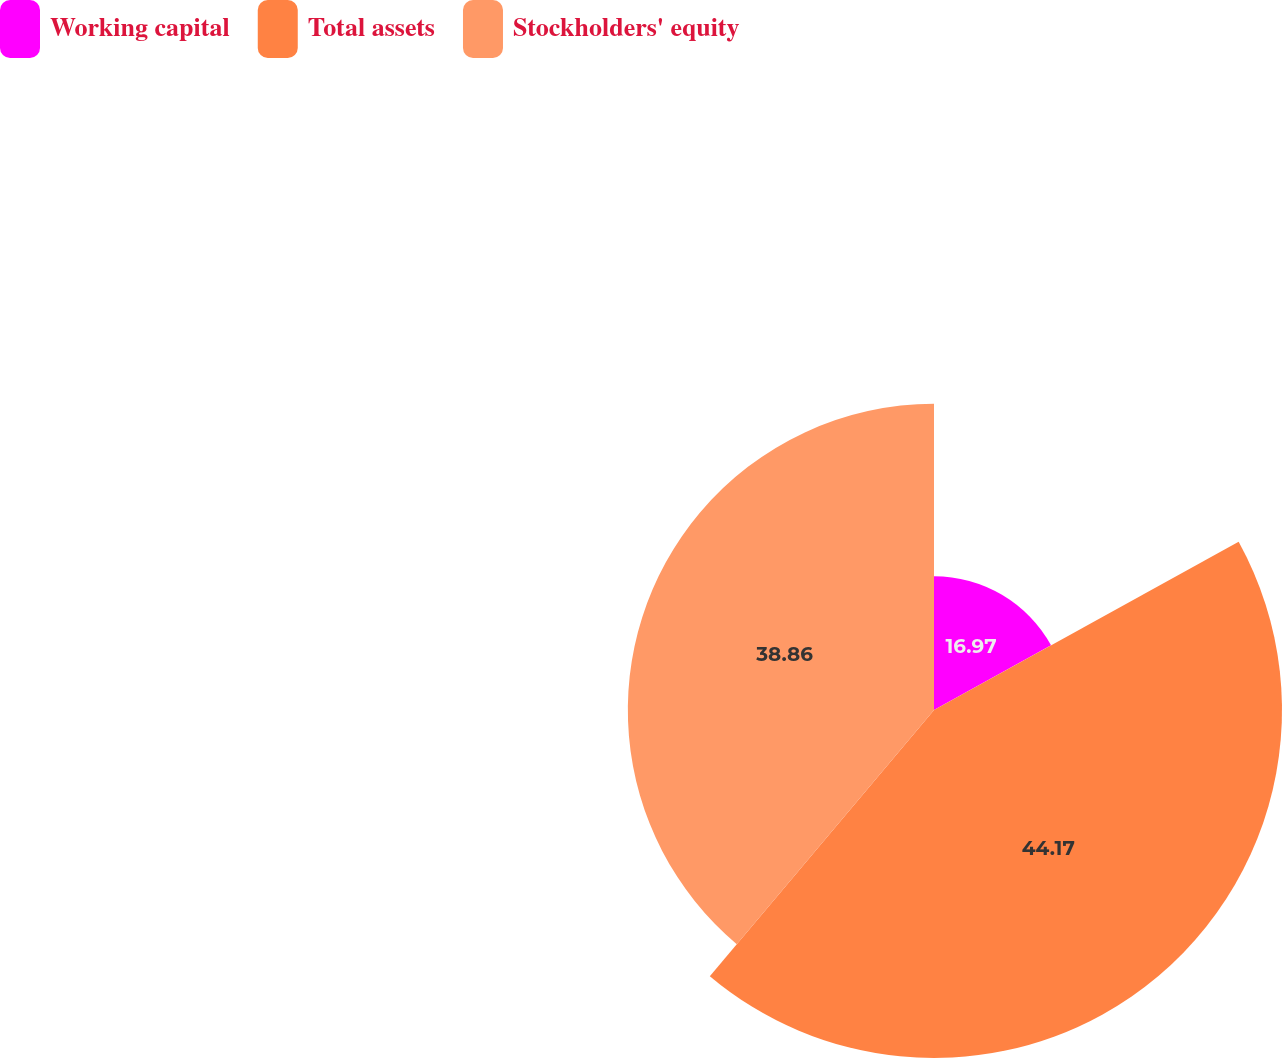Convert chart to OTSL. <chart><loc_0><loc_0><loc_500><loc_500><pie_chart><fcel>Working capital<fcel>Total assets<fcel>Stockholders' equity<nl><fcel>16.97%<fcel>44.17%<fcel>38.86%<nl></chart> 